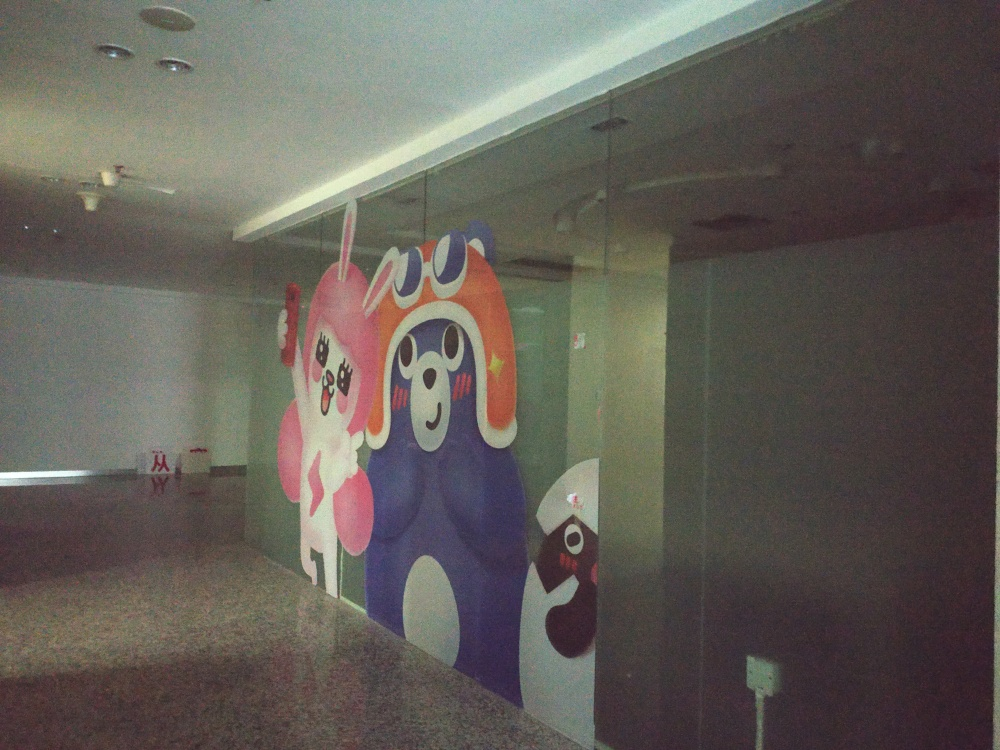What emotions do the characters on the glass evoke? The characters depicted on the glass evoke a sense of joy and playfulness. Their large eyes, wide smiles, and dynamic postures create a friendly and energetic mood. They seem to be engaging with each other in a light-hearted manner, which can bring a smile to viewers and provide a cheerful distraction from the otherwise mundane or sterile surroundings. 